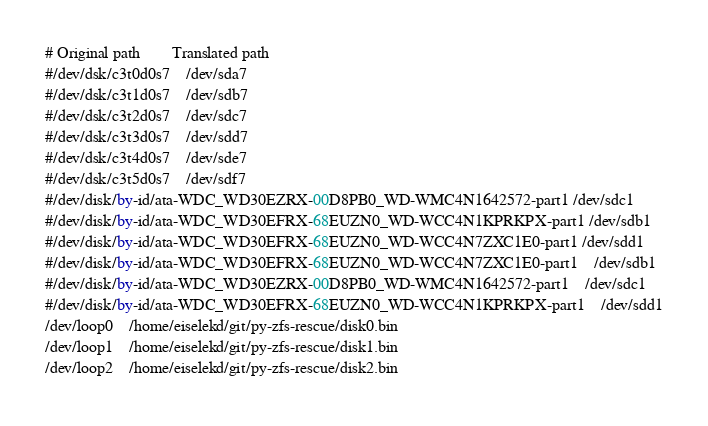<code> <loc_0><loc_0><loc_500><loc_500><_SQL_># Original path		Translated path
#/dev/dsk/c3t0d0s7	/dev/sda7
#/dev/dsk/c3t1d0s7	/dev/sdb7
#/dev/dsk/c3t2d0s7	/dev/sdc7
#/dev/dsk/c3t3d0s7	/dev/sdd7
#/dev/dsk/c3t4d0s7	/dev/sde7
#/dev/dsk/c3t5d0s7	/dev/sdf7
#/dev/disk/by-id/ata-WDC_WD30EZRX-00D8PB0_WD-WMC4N1642572-part1 /dev/sdc1
#/dev/disk/by-id/ata-WDC_WD30EFRX-68EUZN0_WD-WCC4N1KPRKPX-part1 /dev/sdb1
#/dev/disk/by-id/ata-WDC_WD30EFRX-68EUZN0_WD-WCC4N7ZXC1E0-part1 /dev/sdd1
#/dev/disk/by-id/ata-WDC_WD30EFRX-68EUZN0_WD-WCC4N7ZXC1E0-part1	/dev/sdb1
#/dev/disk/by-id/ata-WDC_WD30EZRX-00D8PB0_WD-WMC4N1642572-part1	/dev/sdc1
#/dev/disk/by-id/ata-WDC_WD30EFRX-68EUZN0_WD-WCC4N1KPRKPX-part1	/dev/sdd1
/dev/loop0	/home/eiselekd/git/py-zfs-rescue/disk0.bin
/dev/loop1	/home/eiselekd/git/py-zfs-rescue/disk1.bin
/dev/loop2	/home/eiselekd/git/py-zfs-rescue/disk2.bin
</code> 